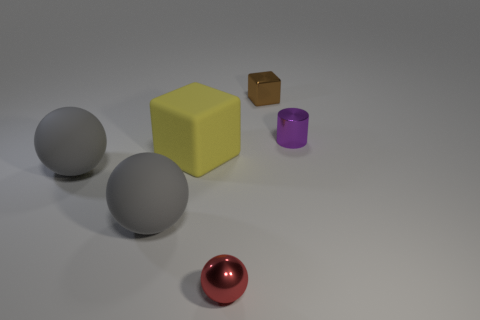Add 1 brown metal balls. How many objects exist? 7 Subtract all blocks. How many objects are left? 4 Subtract all tiny purple things. Subtract all big objects. How many objects are left? 2 Add 6 big gray objects. How many big gray objects are left? 8 Add 6 rubber balls. How many rubber balls exist? 8 Subtract 1 purple cylinders. How many objects are left? 5 